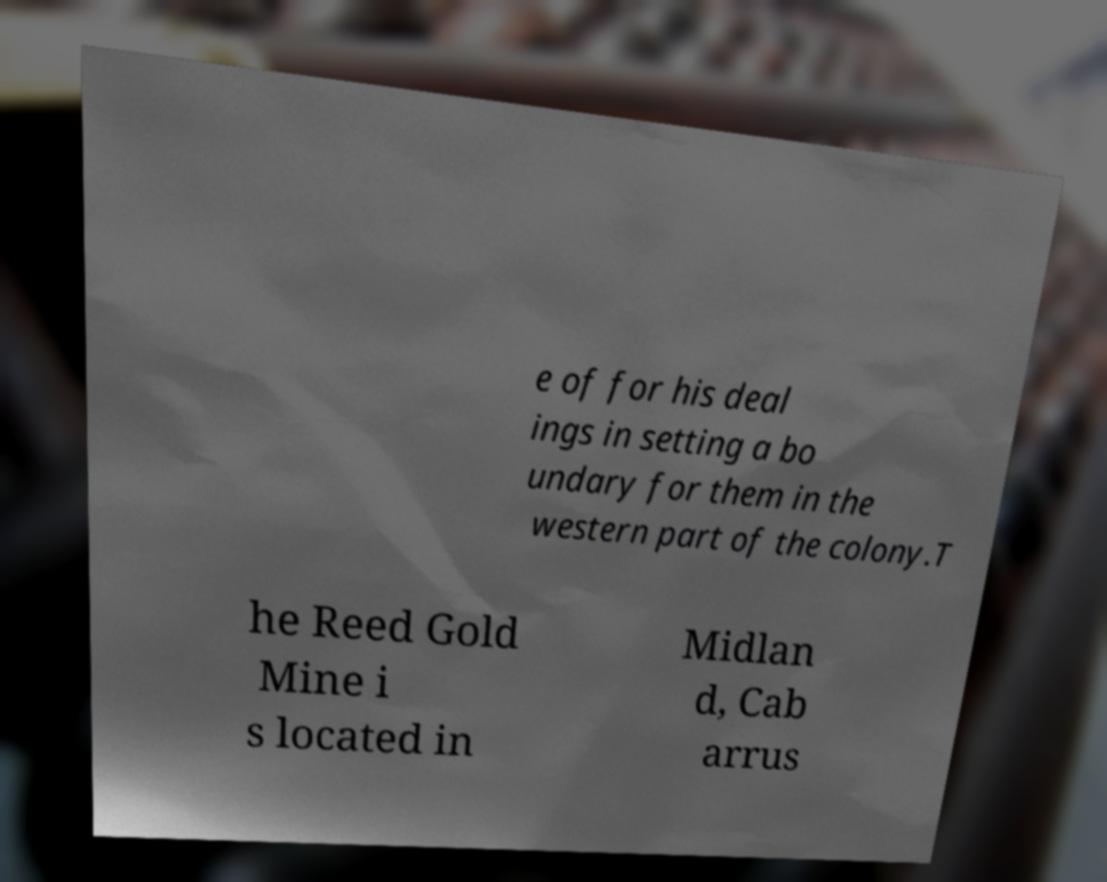For documentation purposes, I need the text within this image transcribed. Could you provide that? e of for his deal ings in setting a bo undary for them in the western part of the colony.T he Reed Gold Mine i s located in Midlan d, Cab arrus 